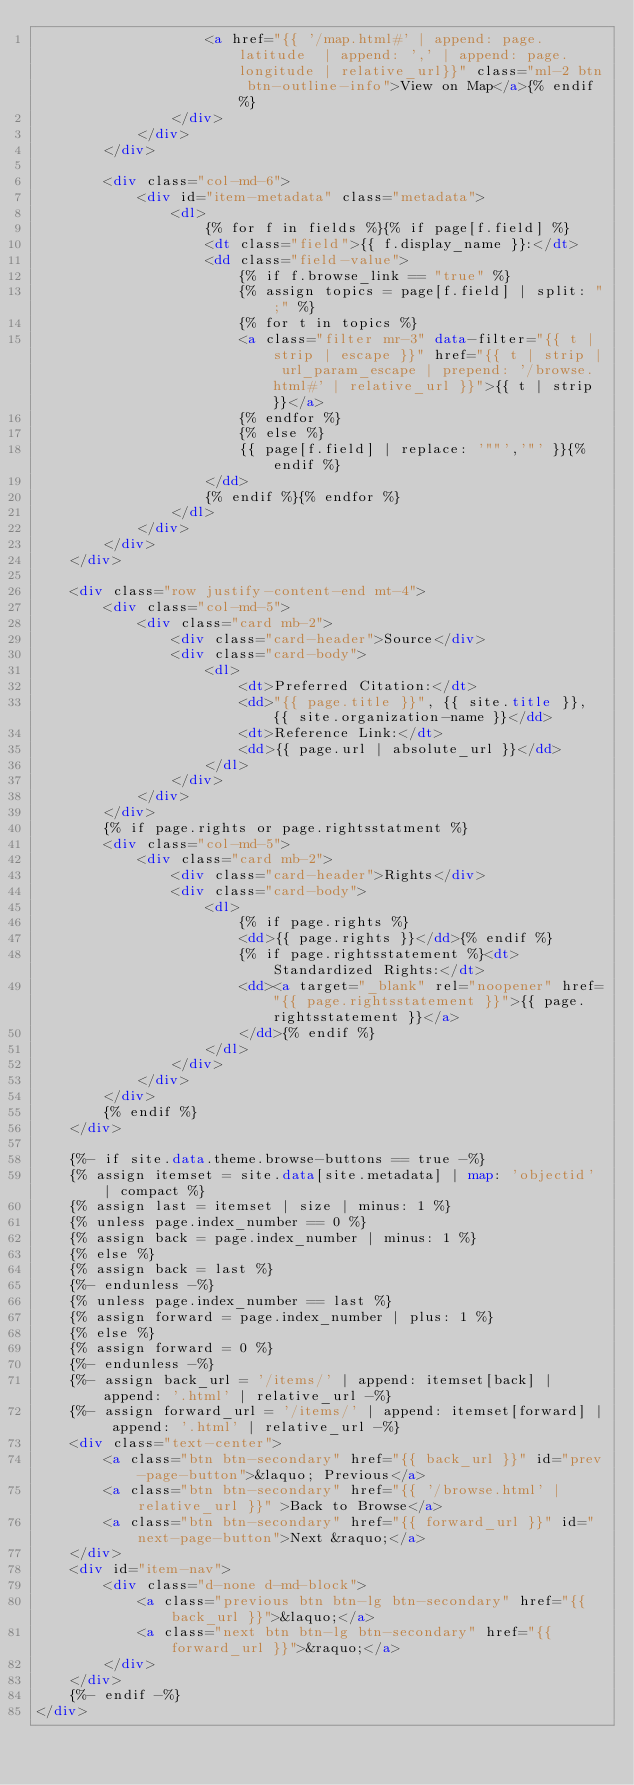<code> <loc_0><loc_0><loc_500><loc_500><_HTML_>                    <a href="{{ '/map.html#' | append: page.latitude  | append: ',' | append: page.longitude | relative_url}}" class="ml-2 btn btn-outline-info">View on Map</a>{% endif %}
                </div>
            </div>
        </div>

        <div class="col-md-6">
            <div id="item-metadata" class="metadata">
                <dl>
                    {% for f in fields %}{% if page[f.field] %}
                    <dt class="field">{{ f.display_name }}:</dt>
                    <dd class="field-value">
                        {% if f.browse_link == "true" %}
                        {% assign topics = page[f.field] | split: ";" %}
                        {% for t in topics %}
                        <a class="filter mr-3" data-filter="{{ t | strip | escape }}" href="{{ t | strip | url_param_escape | prepend: '/browse.html#' | relative_url }}">{{ t | strip }}</a>
                        {% endfor %}
                        {% else %}
                        {{ page[f.field] | replace: '""','"' }}{% endif %}
                    </dd>
                    {% endif %}{% endfor %}
                </dl>
            </div>
        </div>
    </div>

    <div class="row justify-content-end mt-4">
        <div class="col-md-5">
            <div class="card mb-2">
                <div class="card-header">Source</div>
                <div class="card-body">
                    <dl>
                        <dt>Preferred Citation:</dt>
                        <dd>"{{ page.title }}", {{ site.title }}, {{ site.organization-name }}</dd>
                        <dt>Reference Link:</dt>
                        <dd>{{ page.url | absolute_url }}</dd>
                    </dl>
                </div>
            </div>
        </div>
        {% if page.rights or page.rightsstatment %}
        <div class="col-md-5">
            <div class="card mb-2">
                <div class="card-header">Rights</div>
                <div class="card-body">
                    <dl>
                        {% if page.rights %}
                        <dd>{{ page.rights }}</dd>{% endif %}
                        {% if page.rightsstatement %}<dt>Standardized Rights:</dt>
                        <dd><a target="_blank" rel="noopener" href="{{ page.rightsstatement }}">{{ page.rightsstatement }}</a>
                        </dd>{% endif %}
                    </dl>
                </div>
            </div>
        </div>
        {% endif %}
    </div>

    {%- if site.data.theme.browse-buttons == true -%}
    {% assign itemset = site.data[site.metadata] | map: 'objectid' | compact %}
    {% assign last = itemset | size | minus: 1 %}
    {% unless page.index_number == 0 %}
    {% assign back = page.index_number | minus: 1 %}
    {% else %}
    {% assign back = last %}
    {%- endunless -%}
    {% unless page.index_number == last %}
    {% assign forward = page.index_number | plus: 1 %}
    {% else %}
    {% assign forward = 0 %}
    {%- endunless -%}
    {%- assign back_url = '/items/' | append: itemset[back] | append: '.html' | relative_url -%}
    {%- assign forward_url = '/items/' | append: itemset[forward] | append: '.html' | relative_url -%}
    <div class="text-center">
        <a class="btn btn-secondary" href="{{ back_url }}" id="prev-page-button">&laquo; Previous</a>
        <a class="btn btn-secondary" href="{{ '/browse.html' | relative_url }}" >Back to Browse</a>
        <a class="btn btn-secondary" href="{{ forward_url }}" id="next-page-button">Next &raquo;</a>
    </div>
    <div id="item-nav">
        <div class="d-none d-md-block">
            <a class="previous btn btn-lg btn-secondary" href="{{ back_url }}">&laquo;</a>
            <a class="next btn btn-lg btn-secondary" href="{{ forward_url }}">&raquo;</a>
        </div>
    </div>
    {%- endif -%}
</div></code> 